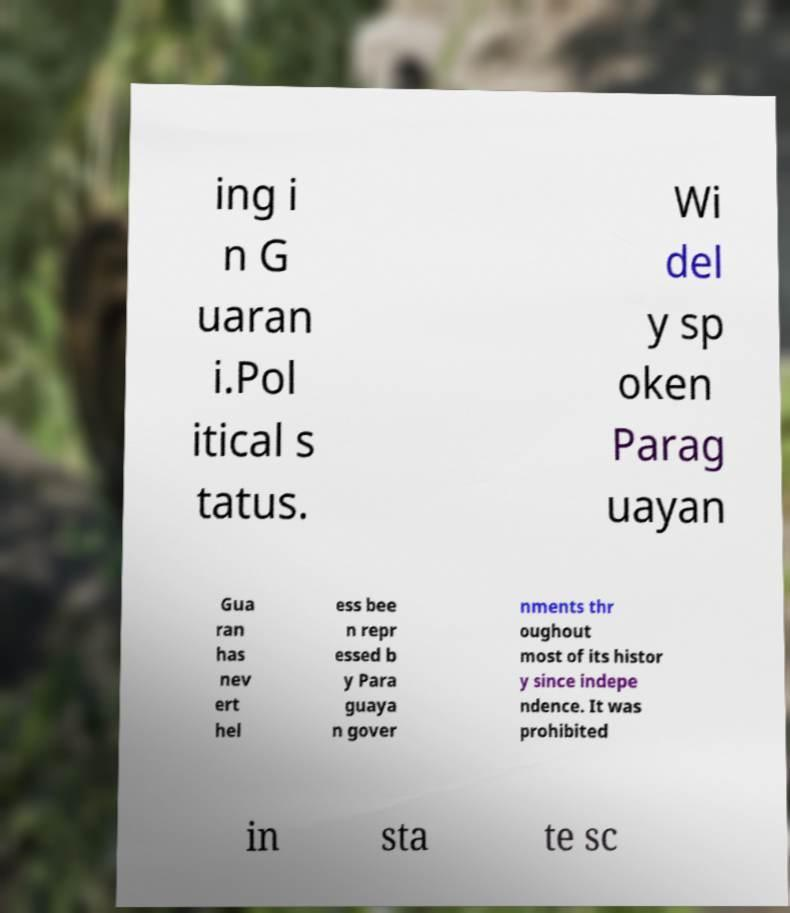There's text embedded in this image that I need extracted. Can you transcribe it verbatim? ing i n G uaran i.Pol itical s tatus. Wi del y sp oken Parag uayan Gua ran has nev ert hel ess bee n repr essed b y Para guaya n gover nments thr oughout most of its histor y since indepe ndence. It was prohibited in sta te sc 